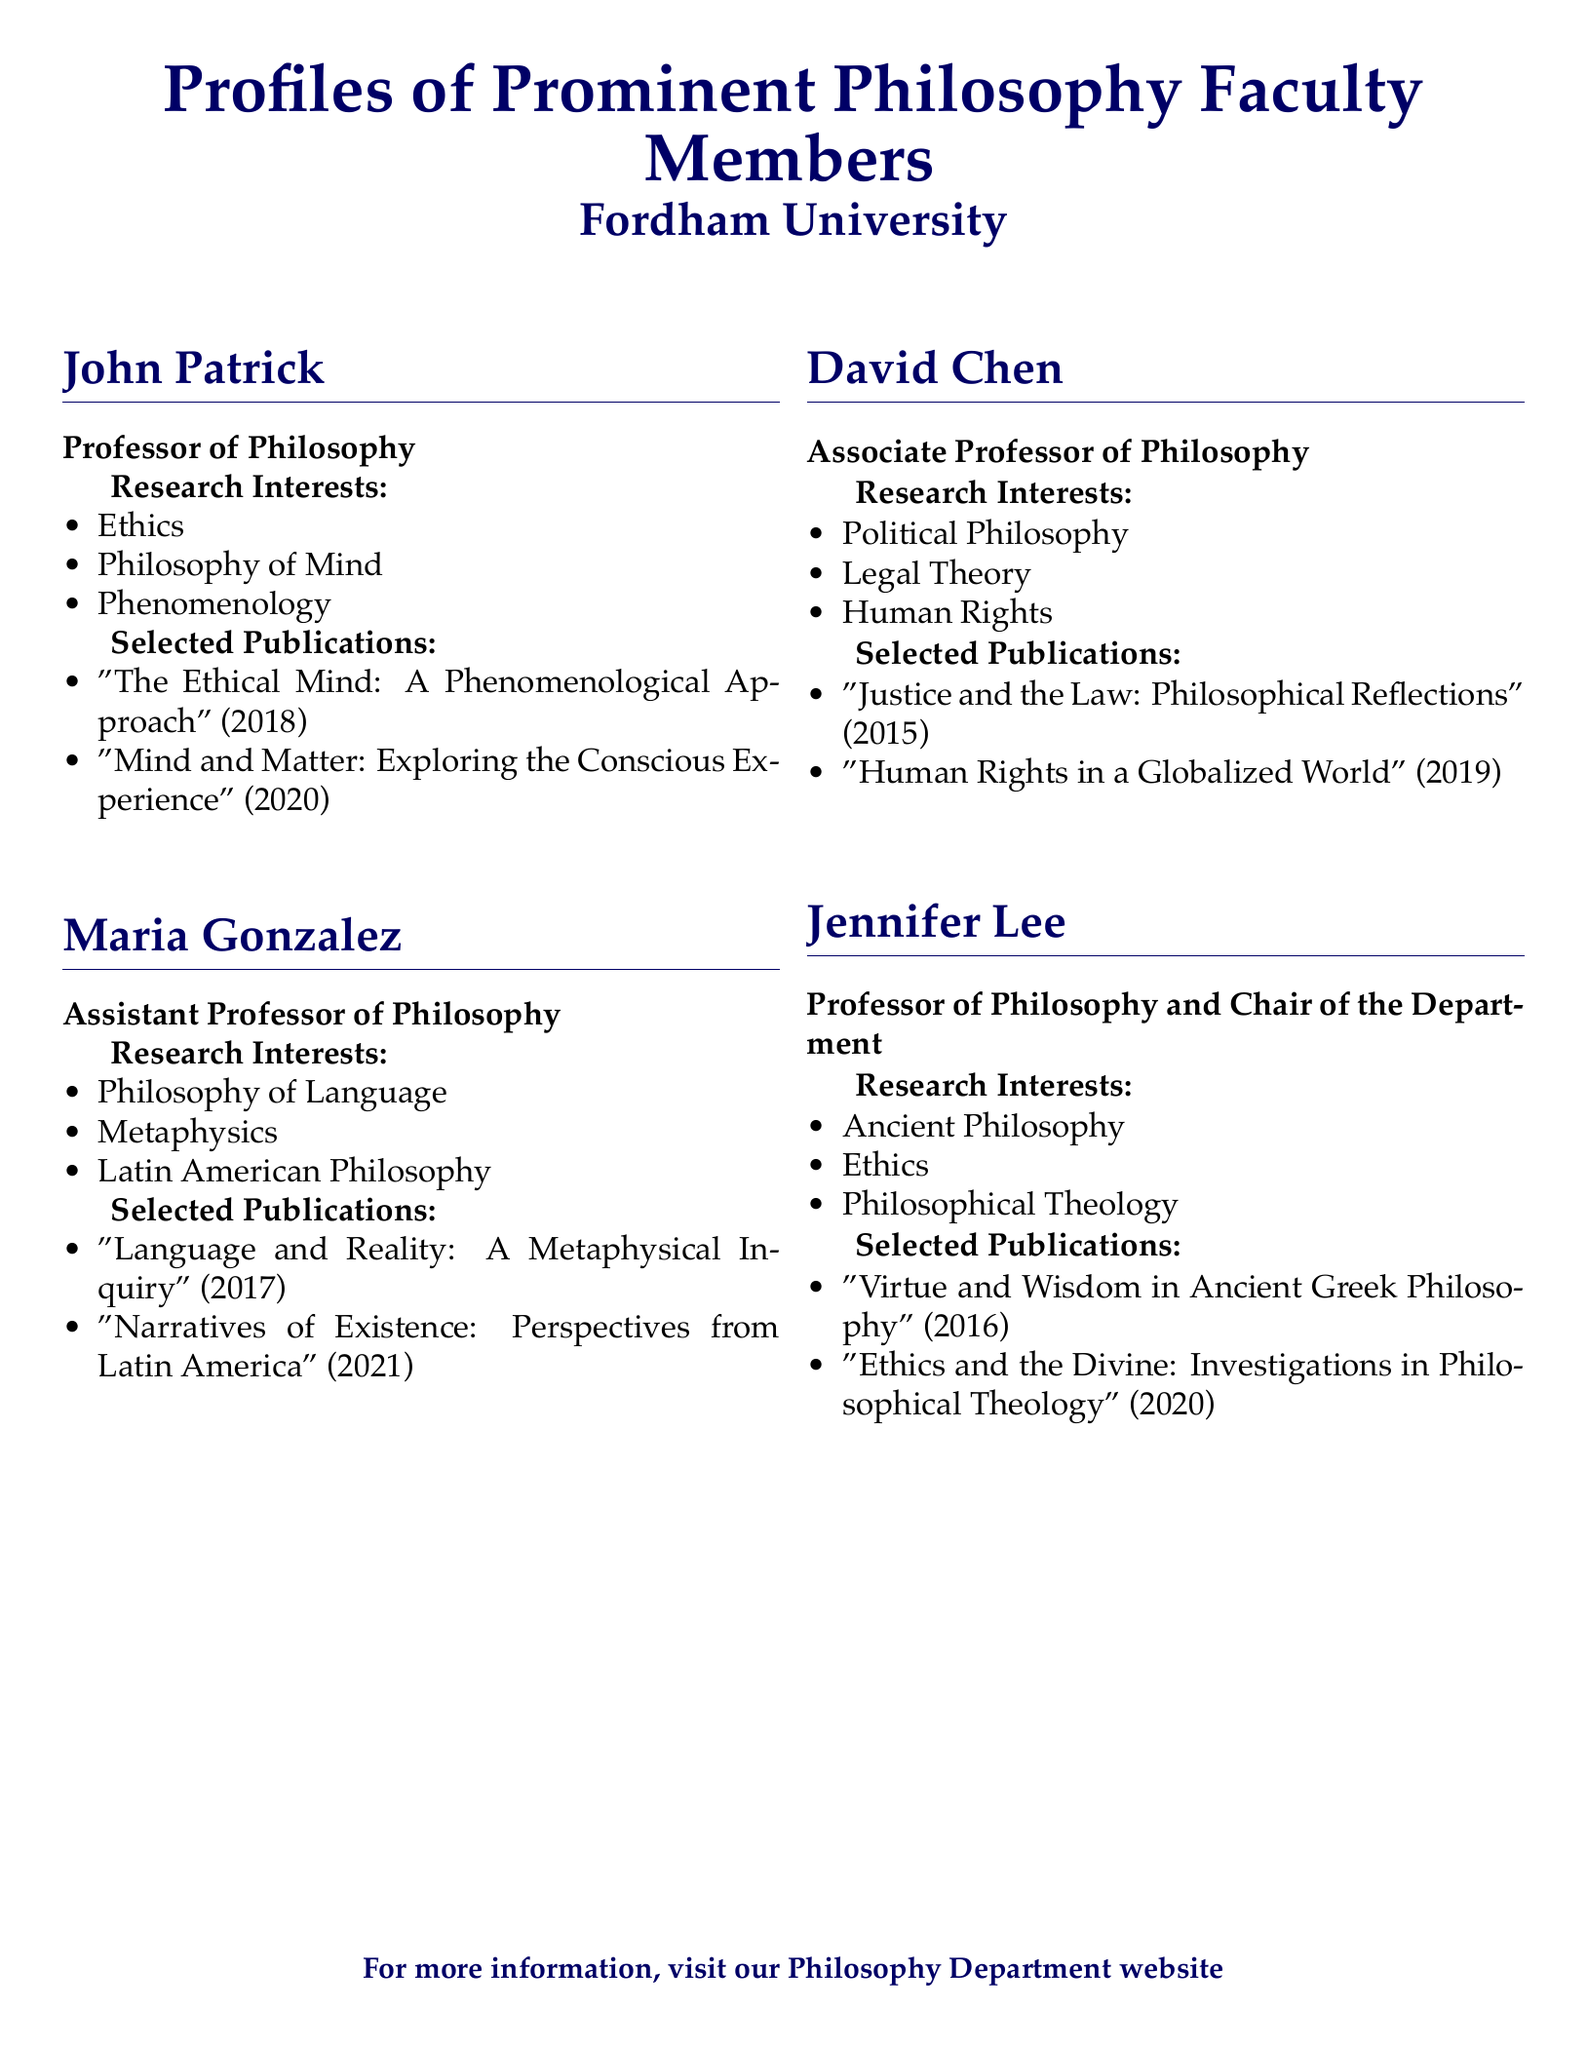What is the name of the Professor of Philosophy who focuses on Ethics? The document states that John Patrick is the Professor of Philosophy with a focus on Ethics.
Answer: John Patrick How many selected publications does Maria Gonzalez have listed? The document shows that Maria Gonzalez has two selected publications listed.
Answer: 2 What research interest is shared by both John Patrick and Jennifer Lee? Both John Patrick and Jennifer Lee have Ethics listed as one of their research interests.
Answer: Ethics Which faculty member is an Associate Professor of Philosophy? The document indicates that David Chen holds the title of Associate Professor of Philosophy.
Answer: David Chen What year was "Language and Reality: A Metaphysical Inquiry" published? The publication date of "Language and Reality: A Metaphysical Inquiry" is found in the document as 2017.
Answer: 2017 What is the focus of Jennifer Lee's philosophical research? The document lists Ancient Philosophy, Ethics, and Philosophical Theology as the focuses of Jennifer Lee's research.
Answer: Ancient Philosophy, Ethics, Philosophical Theology How many research interests does David Chen have listed? The document details that David Chen has three research interests listed.
Answer: 3 Which faculty member oversees the Philosophy Department? The document designates Jennifer Lee as the Chair of the Department, overseeing the Philosophy Department.
Answer: Jennifer Lee 